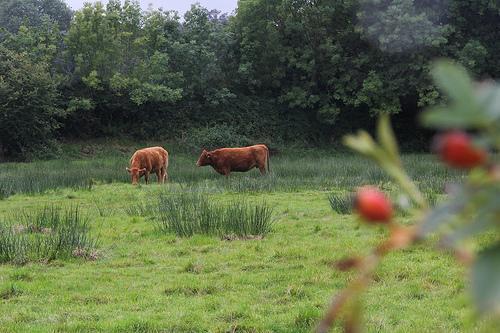How many red objects are visible in the photo?
Give a very brief answer. 2. How many cows are in this scene?
Give a very brief answer. 2. 